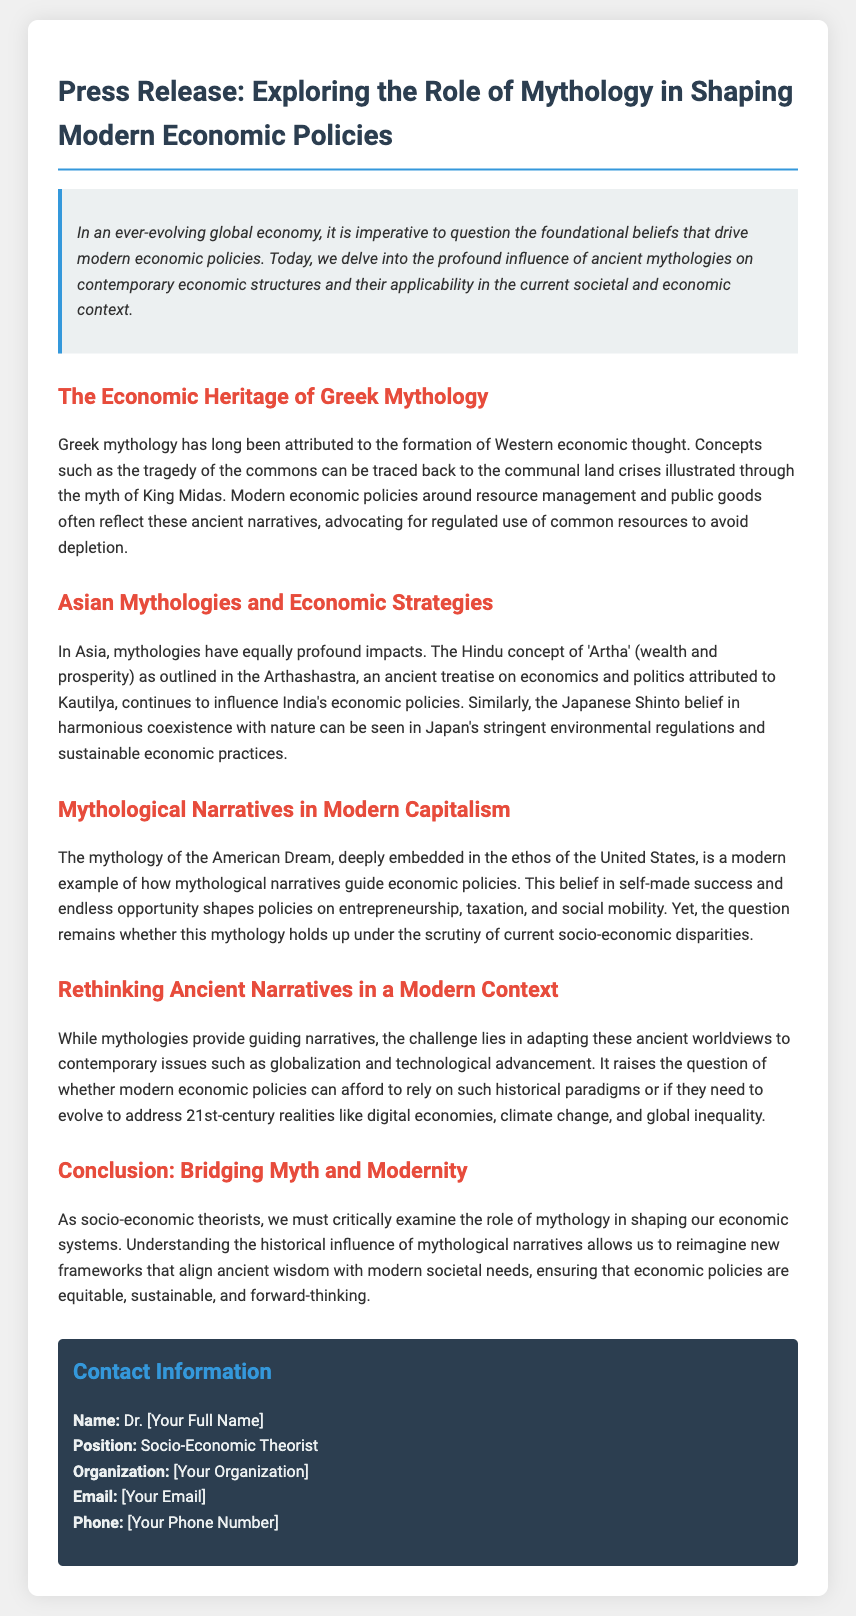What is the title of the press release? The title of the press release is explicitly stated at the beginning of the document.
Answer: Exploring the Role of Mythology in Shaping Modern Economic Policies Who is the press release aimed at? The introduction suggests the document is directed towards socio-economic theorists and policymakers.
Answer: Socio-economic theorists What ancient treatise is associated with Hindu economic concepts? The press release mentions a specific ancient text that outlines economic and political ideas in Hinduism.
Answer: Arthashastra Which modern mythology is discussed concerning the United States? The document describes a particular narrative associated with American culture and economic beliefs.
Answer: American Dream What is the main challenge mentioned regarding ancient narratives? The document points out a specific issue related to the adaptation of ancient beliefs to modern times.
Answer: Adapting to contemporary issues How does Japanese Shinto belief influence economic practices? The section on Asian mythologies specifies a cultural belief impacting regulations and practices in Japan.
Answer: Harmonious coexistence with nature What is a key theme in the conclusion? The conclusion highlights an important idea that ties together mythological influence and modern economic needs.
Answer: Bridging Myth and Modernity What concept from Greek mythology is mentioned in relation to economic thought? The text refers to a particular concept derived from Greek mythology that affects resource management strategies.
Answer: Tragedy of the commons Who is the author of the press release? The contact information section provides the full name of the person who authored the document.
Answer: Dr. [Your Full Name] 